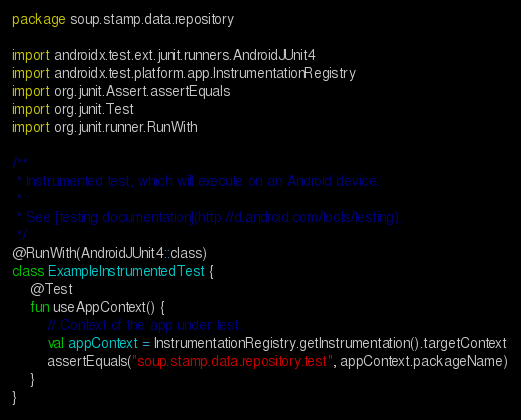<code> <loc_0><loc_0><loc_500><loc_500><_Kotlin_>package soup.stamp.data.repository

import androidx.test.ext.junit.runners.AndroidJUnit4
import androidx.test.platform.app.InstrumentationRegistry
import org.junit.Assert.assertEquals
import org.junit.Test
import org.junit.runner.RunWith

/**
 * Instrumented test, which will execute on an Android device.
 *
 * See [testing documentation](http://d.android.com/tools/testing).
 */
@RunWith(AndroidJUnit4::class)
class ExampleInstrumentedTest {
    @Test
    fun useAppContext() {
        // Context of the app under test.
        val appContext = InstrumentationRegistry.getInstrumentation().targetContext
        assertEquals("soup.stamp.data.repository.test", appContext.packageName)
    }
}
</code> 